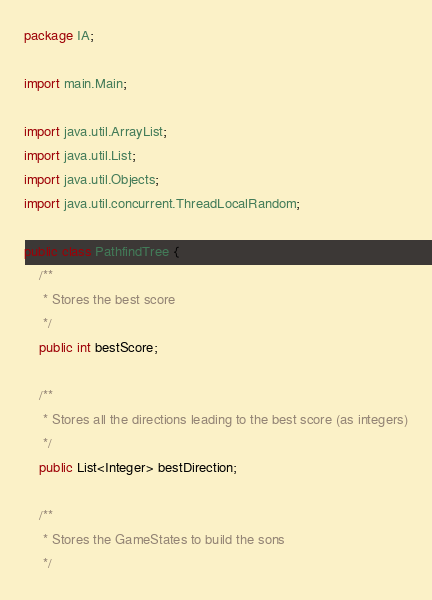<code> <loc_0><loc_0><loc_500><loc_500><_Java_>package IA;

import main.Main;

import java.util.ArrayList;
import java.util.List;
import java.util.Objects;
import java.util.concurrent.ThreadLocalRandom;

public class PathfindTree {
    /**
     * Stores the best score
     */
    public int bestScore;

    /**
     * Stores all the directions leading to the best score (as integers)
     */
    public List<Integer> bestDirection;

    /**
     * Stores the GameStates to build the sons
     */</code> 